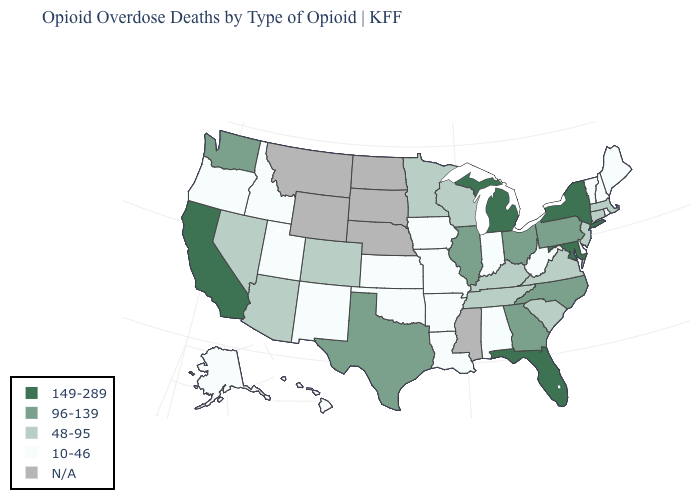Is the legend a continuous bar?
Write a very short answer. No. What is the value of Georgia?
Short answer required. 96-139. Name the states that have a value in the range 48-95?
Keep it brief. Arizona, Colorado, Connecticut, Kentucky, Massachusetts, Minnesota, Nevada, New Jersey, South Carolina, Tennessee, Virginia, Wisconsin. What is the lowest value in states that border New Jersey?
Keep it brief. 10-46. Does Alabama have the lowest value in the USA?
Concise answer only. Yes. Name the states that have a value in the range N/A?
Give a very brief answer. Mississippi, Montana, Nebraska, North Dakota, South Dakota, Wyoming. Does New York have the highest value in the Northeast?
Quick response, please. Yes. What is the highest value in the USA?
Concise answer only. 149-289. Name the states that have a value in the range N/A?
Give a very brief answer. Mississippi, Montana, Nebraska, North Dakota, South Dakota, Wyoming. Name the states that have a value in the range 149-289?
Short answer required. California, Florida, Maryland, Michigan, New York. Name the states that have a value in the range 10-46?
Keep it brief. Alabama, Alaska, Arkansas, Delaware, Hawaii, Idaho, Indiana, Iowa, Kansas, Louisiana, Maine, Missouri, New Hampshire, New Mexico, Oklahoma, Oregon, Rhode Island, Utah, Vermont, West Virginia. Name the states that have a value in the range 96-139?
Concise answer only. Georgia, Illinois, North Carolina, Ohio, Pennsylvania, Texas, Washington. What is the highest value in states that border Ohio?
Short answer required. 149-289. Among the states that border Missouri , which have the highest value?
Concise answer only. Illinois. 